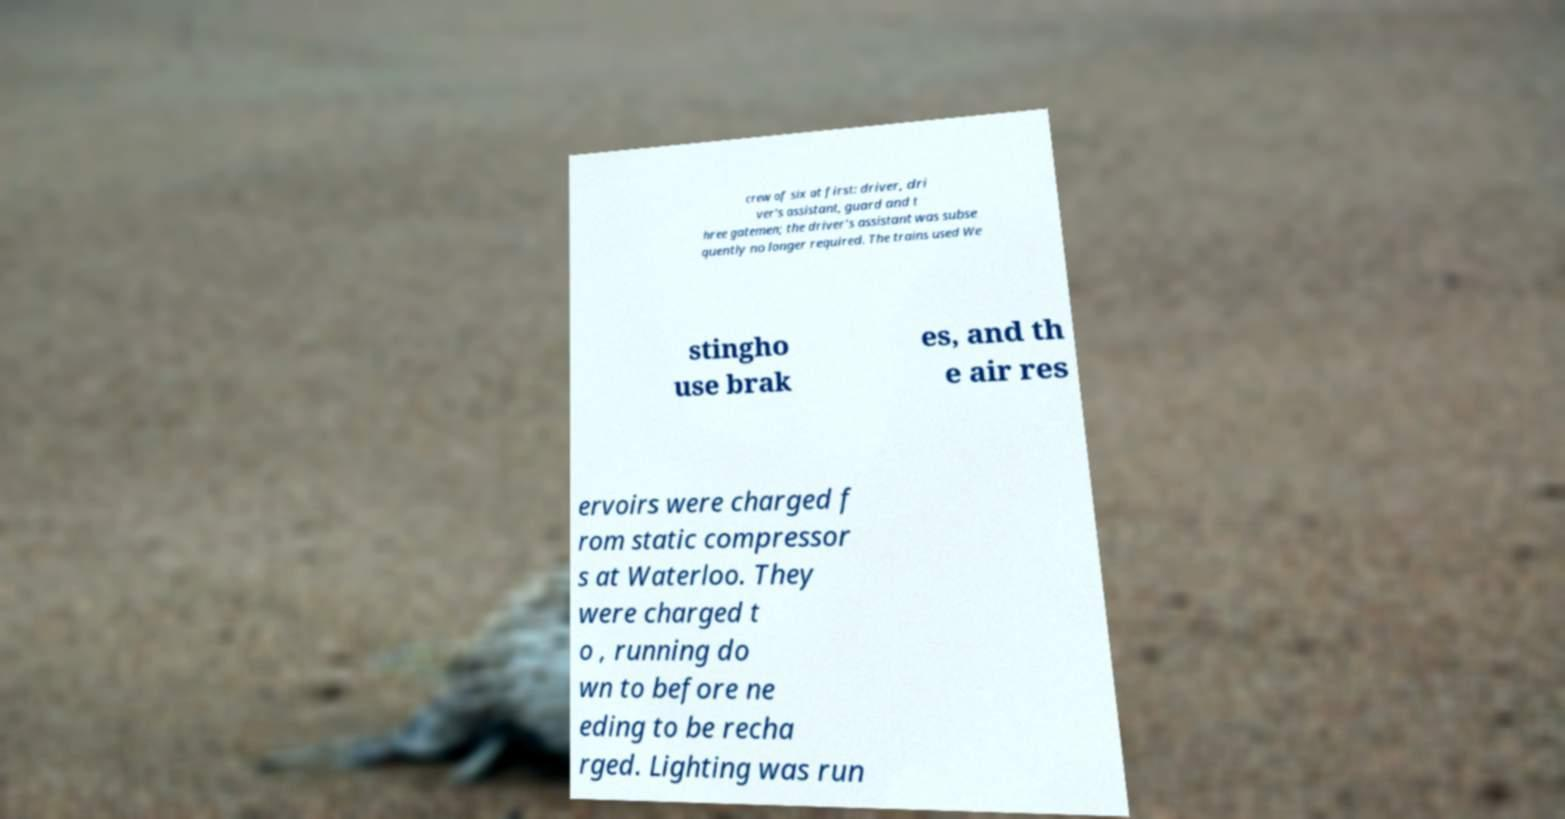Can you read and provide the text displayed in the image?This photo seems to have some interesting text. Can you extract and type it out for me? crew of six at first: driver, dri ver's assistant, guard and t hree gatemen; the driver's assistant was subse quently no longer required. The trains used We stingho use brak es, and th e air res ervoirs were charged f rom static compressor s at Waterloo. They were charged t o , running do wn to before ne eding to be recha rged. Lighting was run 